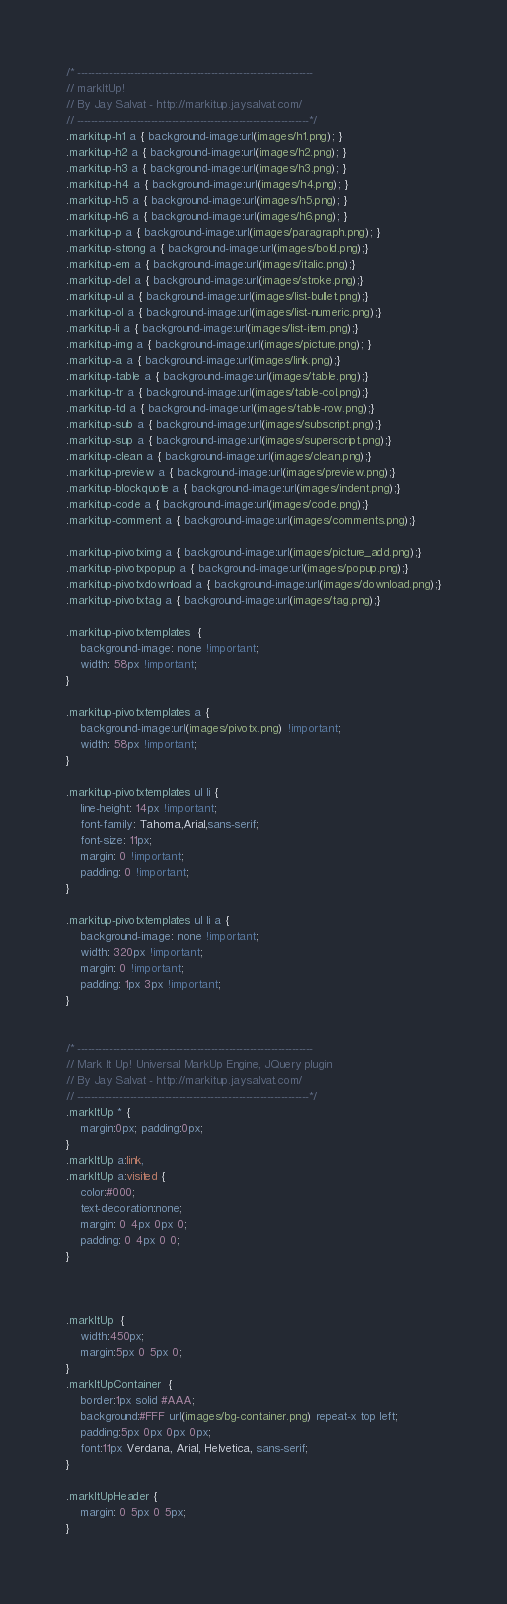<code> <loc_0><loc_0><loc_500><loc_500><_CSS_>/* -------------------------------------------------------------------
// markItUp!
// By Jay Salvat - http://markitup.jaysalvat.com/
// ------------------------------------------------------------------*/
.markitup-h1 a { background-image:url(images/h1.png); }
.markitup-h2 a { background-image:url(images/h2.png); }
.markitup-h3 a { background-image:url(images/h3.png); }
.markitup-h4 a { background-image:url(images/h4.png); }
.markitup-h5 a { background-image:url(images/h5.png); }
.markitup-h6 a { background-image:url(images/h6.png); }
.markitup-p a { background-image:url(images/paragraph.png); }
.markitup-strong a { background-image:url(images/bold.png);}
.markitup-em a { background-image:url(images/italic.png);}
.markitup-del a { background-image:url(images/stroke.png);}
.markitup-ul a { background-image:url(images/list-bullet.png);}
.markitup-ol a { background-image:url(images/list-numeric.png);}
.markitup-li a { background-image:url(images/list-item.png);}
.markitup-img a { background-image:url(images/picture.png); }
.markitup-a a { background-image:url(images/link.png);}
.markitup-table a { background-image:url(images/table.png);}
.markitup-tr a { background-image:url(images/table-col.png);}
.markitup-td a { background-image:url(images/table-row.png);}
.markitup-sub a { background-image:url(images/subscript.png);}
.markitup-sup a { background-image:url(images/superscript.png);}
.markitup-clean a { background-image:url(images/clean.png);}
.markitup-preview a { background-image:url(images/preview.png);}
.markitup-blockquote a { background-image:url(images/indent.png);}
.markitup-code a { background-image:url(images/code.png);}
.markitup-comment a { background-image:url(images/comments.png);}

.markitup-pivotximg a { background-image:url(images/picture_add.png);}
.markitup-pivotxpopup a { background-image:url(images/popup.png);}
.markitup-pivotxdownload a { background-image:url(images/download.png);}
.markitup-pivotxtag a { background-image:url(images/tag.png);}

.markitup-pivotxtemplates  { 
    background-image: none !important;
    width: 58px !important;
}

.markitup-pivotxtemplates a { 
    background-image:url(images/pivotx.png) !important;
    width: 58px !important;
}

.markitup-pivotxtemplates ul li { 
    line-height: 14px !important;
    font-family: Tahoma,Arial,sans-serif;
    font-size: 11px;    
    margin: 0 !important;
    padding: 0 !important;
}

.markitup-pivotxtemplates ul li a { 
    background-image: none !important;
    width: 320px !important;
    margin: 0 !important;
    padding: 1px 3px !important;
}


/* -------------------------------------------------------------------
// Mark It Up! Universal MarkUp Engine, JQuery plugin
// By Jay Salvat - http://markitup.jaysalvat.com/
// ------------------------------------------------------------------*/
.markItUp * {
	margin:0px; padding:0px;
}
.markItUp a:link,
.markItUp a:visited {
	color:#000;
	text-decoration:none;
    margin: 0 4px 0px 0;
    padding: 0 4px 0 0;
}



.markItUp  {
	width:450px;
	margin:5px 0 5px 0;
}
.markItUpContainer  {
	border:1px solid #AAA;	
	background:#FFF url(images/bg-container.png) repeat-x top left;
	padding:5px 0px 0px 0px;
	font:11px Verdana, Arial, Helvetica, sans-serif;
}

.markItUpHeader {
    margin: 0 5px 0 5px;
}
</code> 